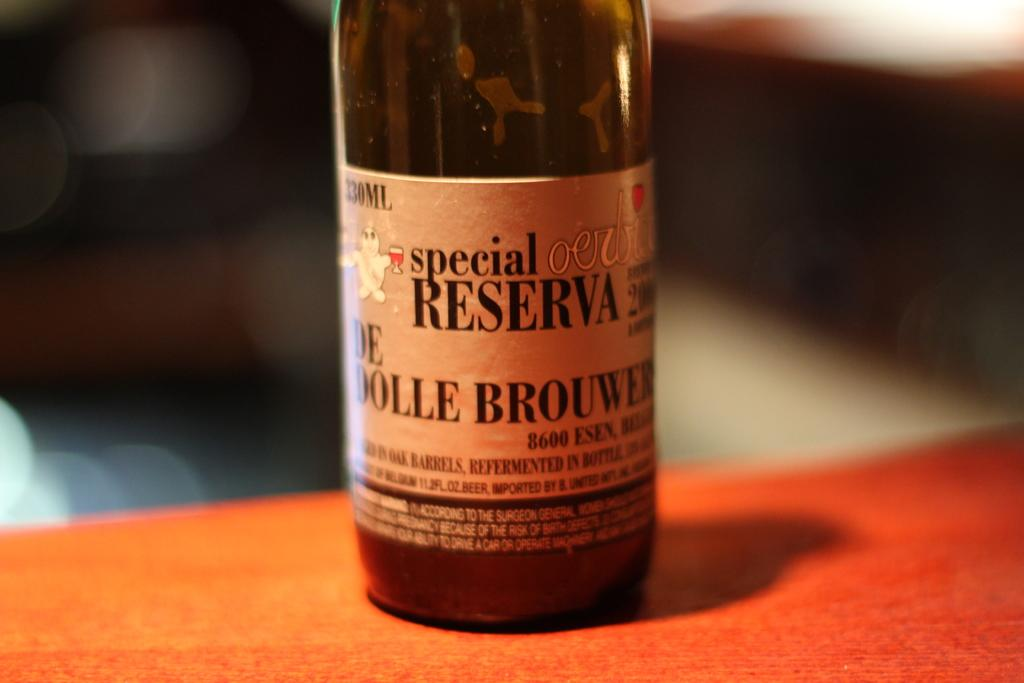<image>
Provide a brief description of the given image. a special reserva bottle on an orange tabletop 